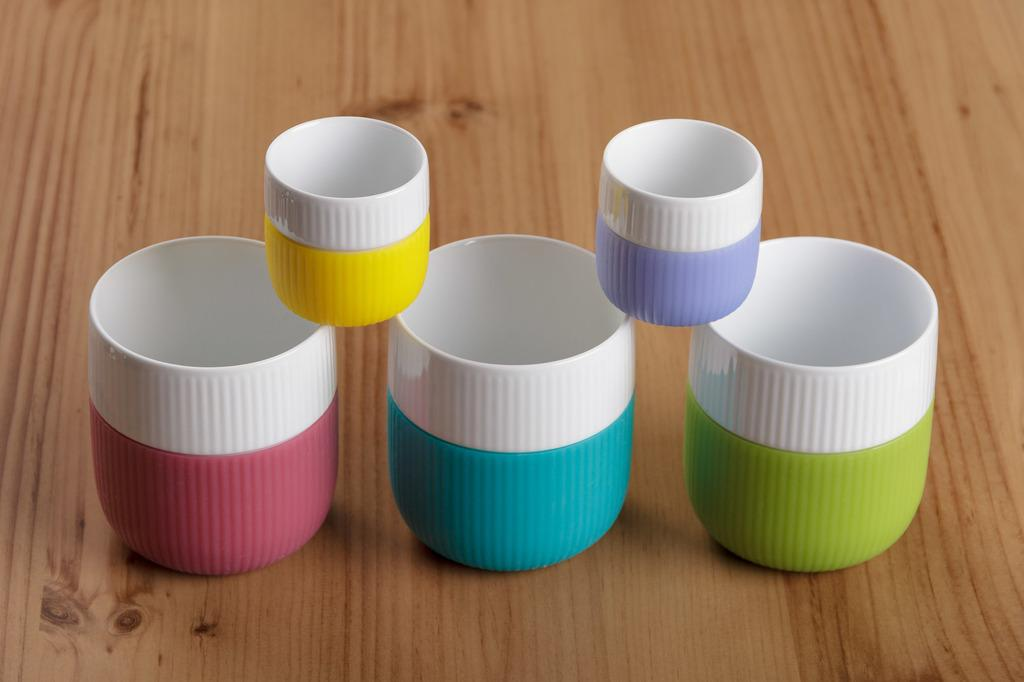How many cups are visible in the image? There are 5 colorful cups in the image. What is the color of the surface on which the cups are placed? The cups are on a brown color surface. What type of yoke is being used to carry the cups in the image? There is no yoke present in the image; the cups are simply placed on a surface. How does the tongue interact with the cups in the image? There is no tongue present in the image, as it is not a living being or an entity capable of interacting with the cups. 